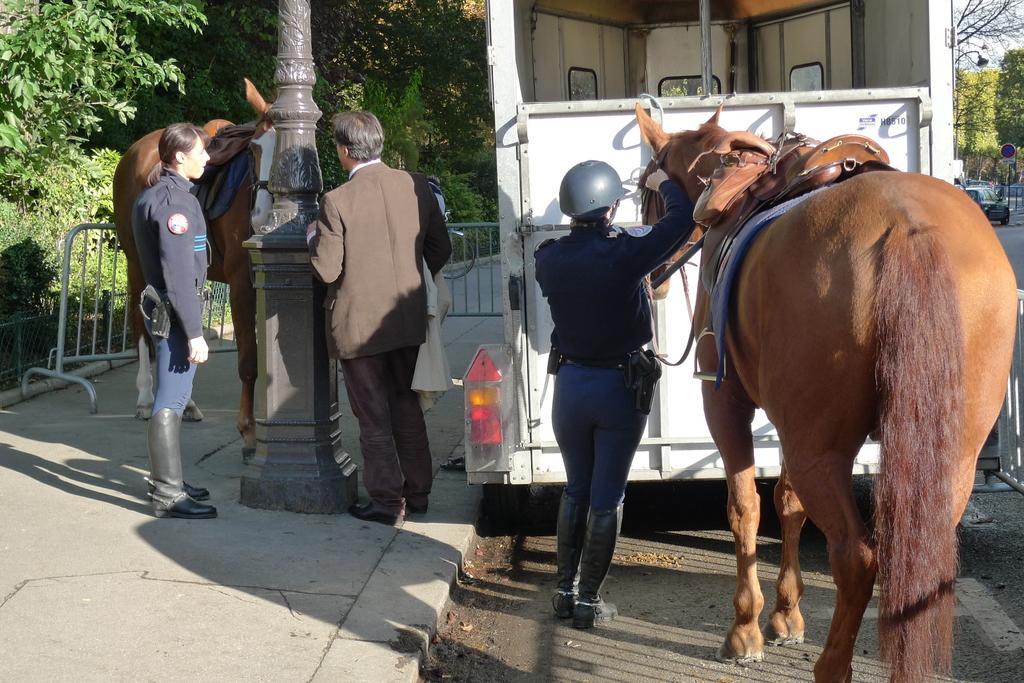In one or two sentences, can you explain what this image depicts? in this image i can see a horse and a person wearing a helmet is holding the horse. behind them there is a vehicle. behind them there are two more people and a pillar in between. behind them there is a horse. behind all these there are many trees and a fencing at the front.. at the rightmost there is a car and a sign board. 